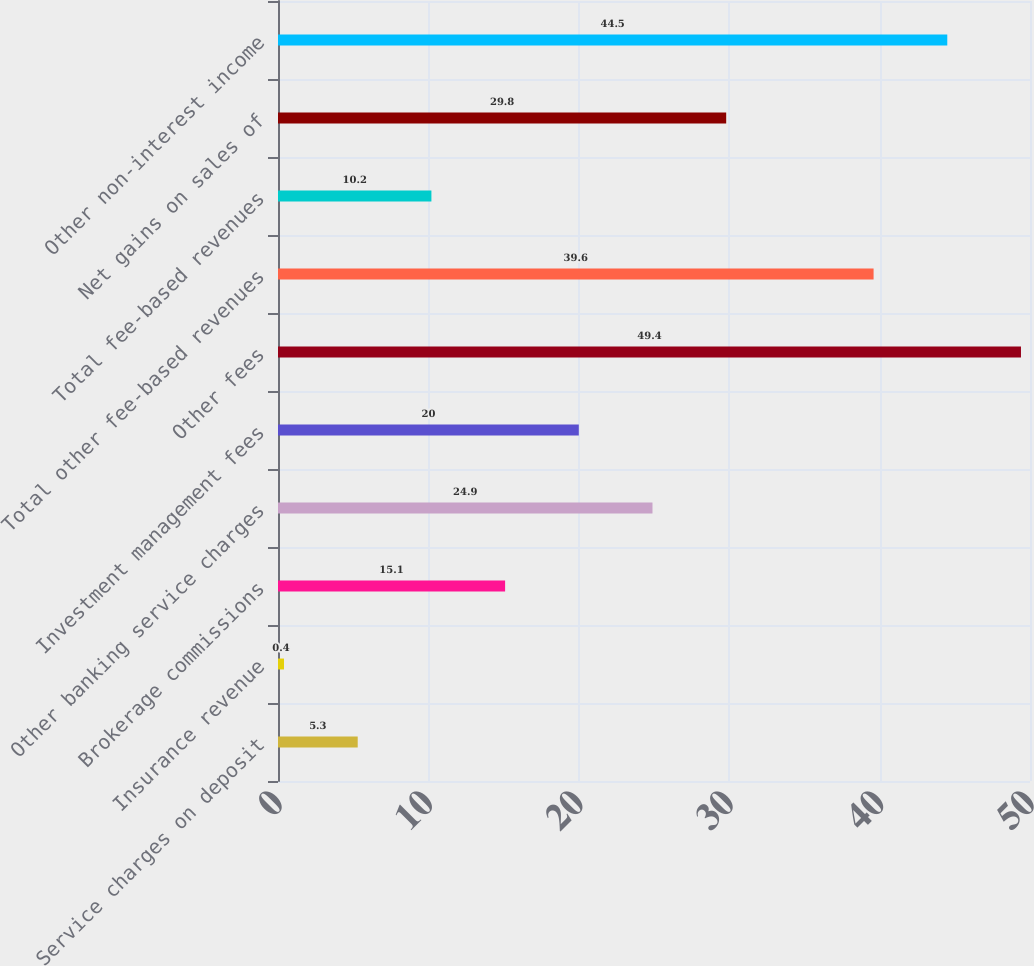Convert chart to OTSL. <chart><loc_0><loc_0><loc_500><loc_500><bar_chart><fcel>Service charges on deposit<fcel>Insurance revenue<fcel>Brokerage commissions<fcel>Other banking service charges<fcel>Investment management fees<fcel>Other fees<fcel>Total other fee-based revenues<fcel>Total fee-based revenues<fcel>Net gains on sales of<fcel>Other non-interest income<nl><fcel>5.3<fcel>0.4<fcel>15.1<fcel>24.9<fcel>20<fcel>49.4<fcel>39.6<fcel>10.2<fcel>29.8<fcel>44.5<nl></chart> 